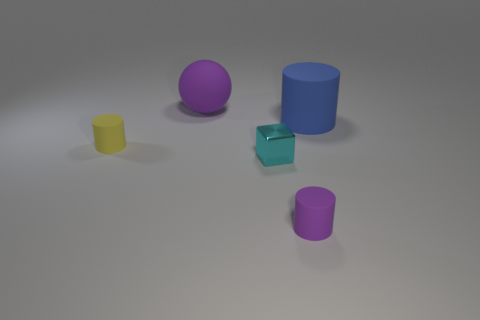Is there any other thing that is made of the same material as the cyan cube?
Provide a short and direct response. No. What number of tiny cyan objects are right of the purple cylinder?
Offer a terse response. 0. What material is the object that is both right of the small cyan metallic block and on the left side of the big blue object?
Give a very brief answer. Rubber. What number of small things are either rubber cylinders or cyan objects?
Your answer should be very brief. 3. The sphere is what size?
Your answer should be very brief. Large. The large blue object has what shape?
Provide a short and direct response. Cylinder. Are there any other things that have the same shape as the large blue matte object?
Your answer should be compact. Yes. Are there fewer yellow rubber cylinders on the left side of the big purple rubber sphere than large blue cylinders?
Make the answer very short. No. Does the big thing to the left of the big rubber cylinder have the same color as the tiny metallic block?
Provide a succinct answer. No. How many matte objects are tiny yellow objects or cylinders?
Provide a short and direct response. 3. 